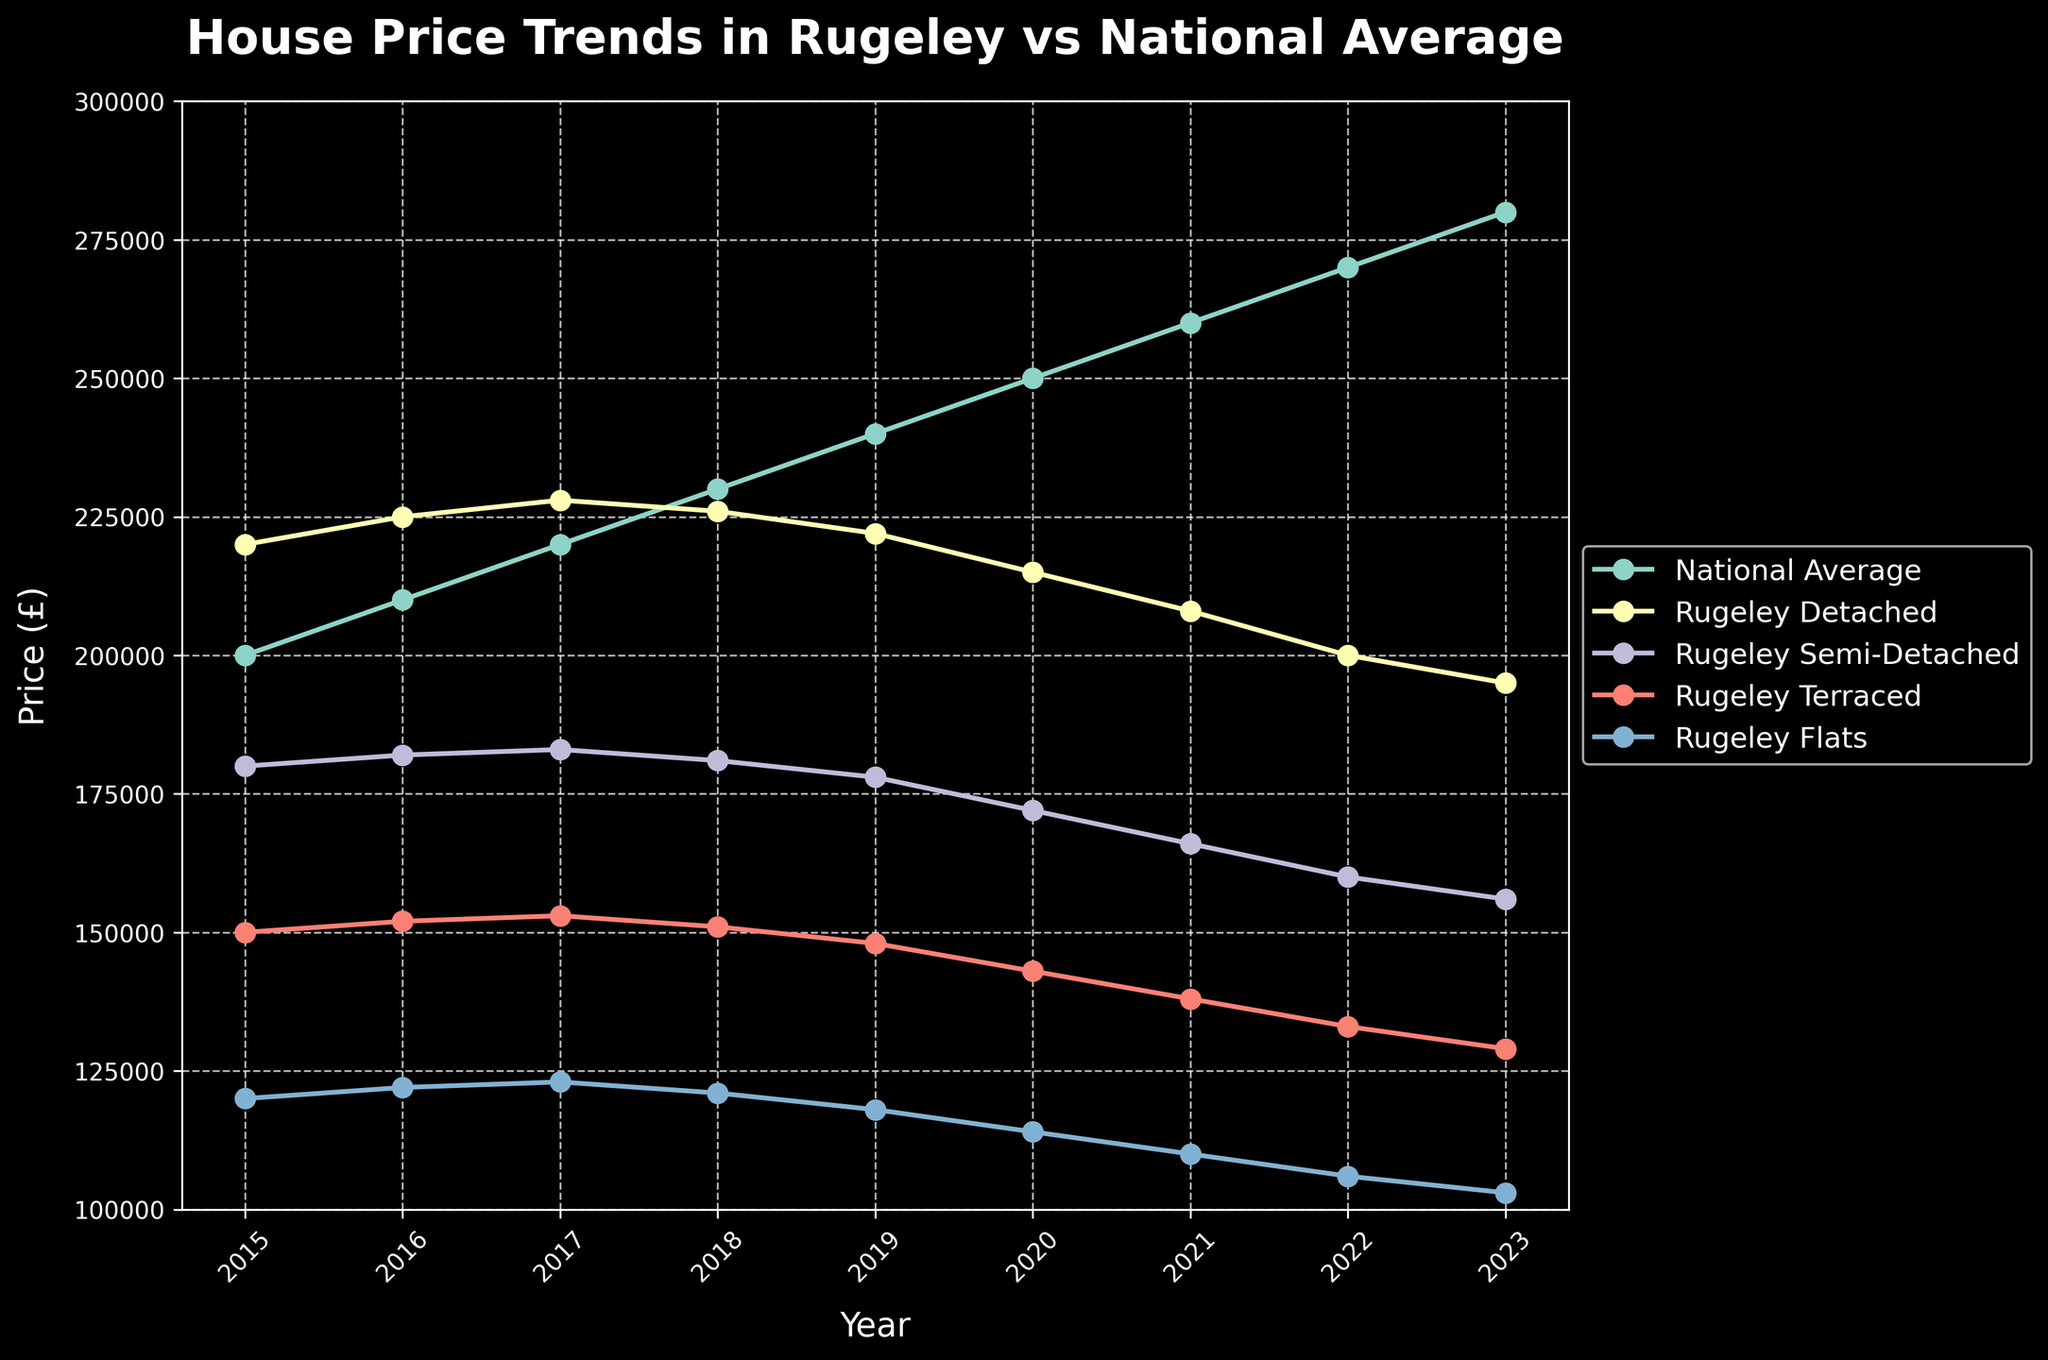What's the trend in the national average house price from 2015 to 2023? The national average house price consistently increases each year from 200,000 in 2015 to 280,000 in 2023. We observe a gradual upward slope in the corresponding line on the chart.
Answer: Increasing How does the price of detached houses in Rugeley in 2023 compare to 2015? In 2015, the price of detached houses in Rugeley was 220,000, and in 2023 it is 195,000. The line for Rugeley Detached shows a downward trend.
Answer: Lower in 2023 Which property type in Rugeley shows the steepest decline in prices from 2015 to 2023? By examining the slopes of the lines for each property type in Rugeley, the "Rugeley Flats" line shows the steepest decline, from 120,000 in 2015 to 103,000 in 2023.
Answer: Flats What is the difference in the price of semi-detached houses in Rugeley between 2016 and 2023? In 2016, the price of semi-detached houses in Rugeley was 182,000, and in 2023 it is 156,000. The difference is 182,000 - 156,000 = 26,000.
Answer: 26,000 How does the 2023 average house price in Rugeley for terraced houses compare with the national average? The national average in 2023 is 280,000, while Rugeley's terraced houses are 129,000. The chart shows the national average considerably higher than the price of terraced houses in Rugeley.
Answer: National average is higher What years did Rugeley Flats prices experience a drop? By observing the line for Rugeley Flats, the prices dropped consistently year by year: 2018, 2019, 2020, 2021, 2022, and 2023.
Answer: 2018-2023 Which year saw the smallest difference between the national average house price and Rugeley’s detached house prices? Calculating the differences: 
- 2015: 220,000 - 200,000 = 20,000 
- 2016: 225,000 - 210,000 = 15,000 
- 2017: 228,000 - 220,000 = 8,000
- 2018: 226,000 - 230,000 = -4,000
2018 had the smallest difference (4,000), even though it was negative.
Answer: 2018 How have the prices of terraced houses in Rugeley changed from the announcement of the closure to 2023? The price decreased from 150,000 in 2015 to 129,000 in 2023. This trend indicates a consistent decrease each year in the corresponding line.
Answer: Decreased What is the average price of semi-detached houses in Rugeley between 2015 and 2023? Sum of prices: 180,000 + 182,000 + 183,000 + 181,000 + 178,000 + 172,000 + 166,000 + 160,000 + 156,000 = 1,558,000. Number of years = 9. Average = 1,558,000 / 9 = 173,111.
Answer: 173,111 Which property type in Rugeley experienced the least change in price between 2015 and 2023? By evaluating the lines' slopes for each property type, "Rugeley Semi-Detached" shows the least change in price, decreasing by 24,000 over the time span (180,000 in 2015 to 156,000 in 2023).
Answer: Semi-Detached 